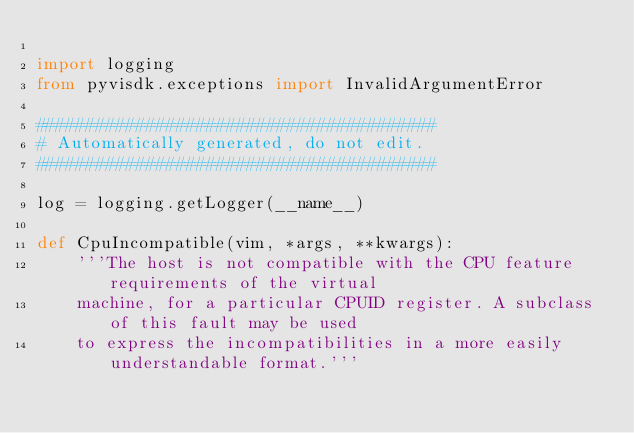Convert code to text. <code><loc_0><loc_0><loc_500><loc_500><_Python_>
import logging
from pyvisdk.exceptions import InvalidArgumentError

########################################
# Automatically generated, do not edit.
########################################

log = logging.getLogger(__name__)

def CpuIncompatible(vim, *args, **kwargs):
    '''The host is not compatible with the CPU feature requirements of the virtual
    machine, for a particular CPUID register. A subclass of this fault may be used
    to express the incompatibilities in a more easily understandable format.'''
</code> 